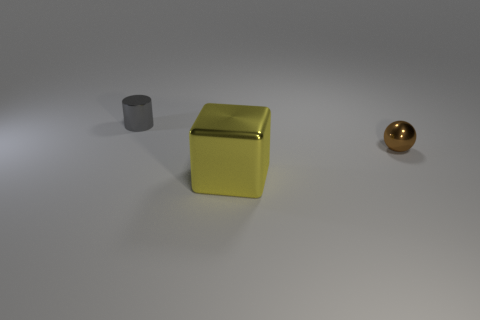Add 2 large yellow shiny blocks. How many objects exist? 5 Subtract 1 cylinders. How many cylinders are left? 0 Subtract all small cylinders. Subtract all tiny objects. How many objects are left? 0 Add 2 gray cylinders. How many gray cylinders are left? 3 Add 3 large yellow metal cubes. How many large yellow metal cubes exist? 4 Subtract 0 blue cylinders. How many objects are left? 3 Subtract all cylinders. How many objects are left? 2 